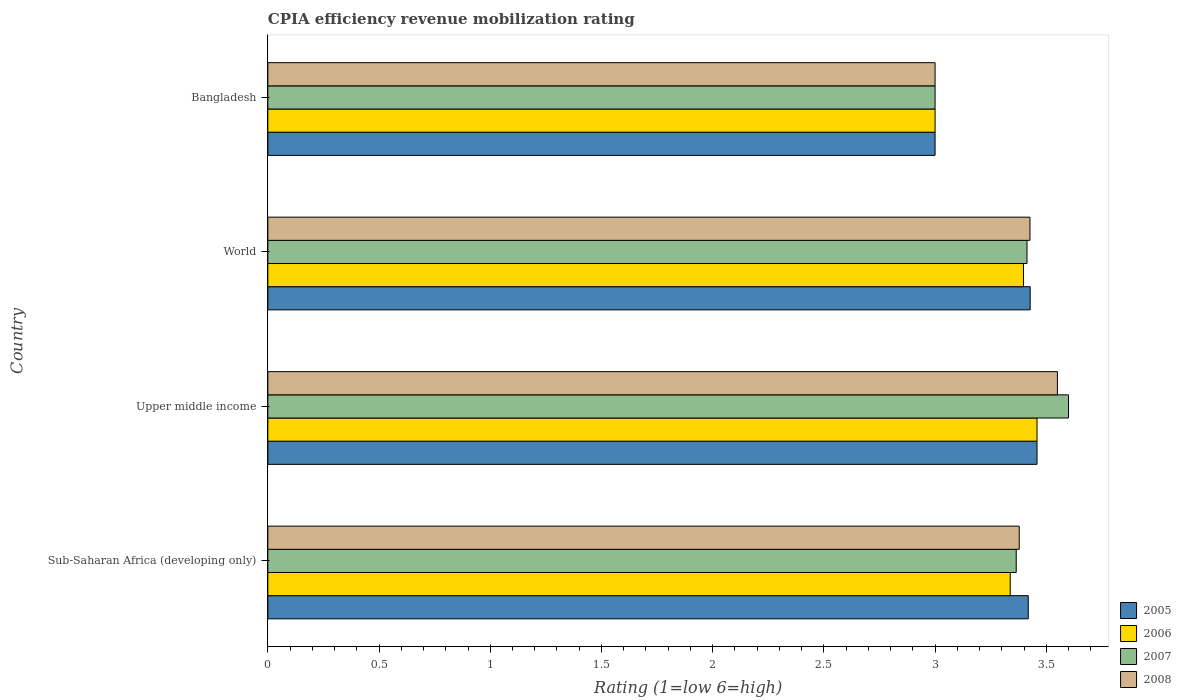How many different coloured bars are there?
Offer a very short reply. 4. How many bars are there on the 2nd tick from the top?
Ensure brevity in your answer.  4. What is the label of the 4th group of bars from the top?
Give a very brief answer. Sub-Saharan Africa (developing only). In how many cases, is the number of bars for a given country not equal to the number of legend labels?
Provide a succinct answer. 0. What is the CPIA rating in 2007 in Upper middle income?
Provide a succinct answer. 3.6. Across all countries, what is the maximum CPIA rating in 2005?
Provide a short and direct response. 3.46. Across all countries, what is the minimum CPIA rating in 2007?
Keep it short and to the point. 3. In which country was the CPIA rating in 2005 maximum?
Your response must be concise. Upper middle income. In which country was the CPIA rating in 2005 minimum?
Ensure brevity in your answer.  Bangladesh. What is the total CPIA rating in 2006 in the graph?
Ensure brevity in your answer.  13.19. What is the difference between the CPIA rating in 2007 in Bangladesh and that in World?
Your answer should be very brief. -0.41. What is the difference between the CPIA rating in 2006 in Bangladesh and the CPIA rating in 2005 in Sub-Saharan Africa (developing only)?
Offer a terse response. -0.42. What is the average CPIA rating in 2006 per country?
Your answer should be very brief. 3.3. What is the difference between the CPIA rating in 2008 and CPIA rating in 2005 in Sub-Saharan Africa (developing only)?
Provide a succinct answer. -0.04. What is the ratio of the CPIA rating in 2007 in Sub-Saharan Africa (developing only) to that in World?
Your answer should be very brief. 0.99. Is the CPIA rating in 2008 in Sub-Saharan Africa (developing only) less than that in World?
Make the answer very short. Yes. Is the difference between the CPIA rating in 2008 in Upper middle income and World greater than the difference between the CPIA rating in 2005 in Upper middle income and World?
Keep it short and to the point. Yes. What is the difference between the highest and the second highest CPIA rating in 2008?
Provide a succinct answer. 0.12. What is the difference between the highest and the lowest CPIA rating in 2007?
Give a very brief answer. 0.6. In how many countries, is the CPIA rating in 2007 greater than the average CPIA rating in 2007 taken over all countries?
Make the answer very short. 3. Is the sum of the CPIA rating in 2007 in Bangladesh and World greater than the maximum CPIA rating in 2006 across all countries?
Give a very brief answer. Yes. Is it the case that in every country, the sum of the CPIA rating in 2006 and CPIA rating in 2005 is greater than the sum of CPIA rating in 2008 and CPIA rating in 2007?
Your response must be concise. No. Are all the bars in the graph horizontal?
Offer a very short reply. Yes. What is the difference between two consecutive major ticks on the X-axis?
Ensure brevity in your answer.  0.5. Does the graph contain grids?
Your answer should be very brief. No. How many legend labels are there?
Your answer should be compact. 4. What is the title of the graph?
Your response must be concise. CPIA efficiency revenue mobilization rating. What is the label or title of the X-axis?
Make the answer very short. Rating (1=low 6=high). What is the label or title of the Y-axis?
Make the answer very short. Country. What is the Rating (1=low 6=high) of 2005 in Sub-Saharan Africa (developing only)?
Your response must be concise. 3.42. What is the Rating (1=low 6=high) in 2006 in Sub-Saharan Africa (developing only)?
Provide a short and direct response. 3.34. What is the Rating (1=low 6=high) in 2007 in Sub-Saharan Africa (developing only)?
Provide a succinct answer. 3.36. What is the Rating (1=low 6=high) of 2008 in Sub-Saharan Africa (developing only)?
Give a very brief answer. 3.38. What is the Rating (1=low 6=high) of 2005 in Upper middle income?
Make the answer very short. 3.46. What is the Rating (1=low 6=high) of 2006 in Upper middle income?
Make the answer very short. 3.46. What is the Rating (1=low 6=high) of 2008 in Upper middle income?
Make the answer very short. 3.55. What is the Rating (1=low 6=high) of 2005 in World?
Offer a very short reply. 3.43. What is the Rating (1=low 6=high) of 2006 in World?
Ensure brevity in your answer.  3.4. What is the Rating (1=low 6=high) in 2007 in World?
Provide a short and direct response. 3.41. What is the Rating (1=low 6=high) in 2008 in World?
Provide a succinct answer. 3.43. What is the Rating (1=low 6=high) of 2008 in Bangladesh?
Offer a very short reply. 3. Across all countries, what is the maximum Rating (1=low 6=high) in 2005?
Ensure brevity in your answer.  3.46. Across all countries, what is the maximum Rating (1=low 6=high) of 2006?
Your answer should be compact. 3.46. Across all countries, what is the maximum Rating (1=low 6=high) of 2007?
Offer a terse response. 3.6. Across all countries, what is the maximum Rating (1=low 6=high) in 2008?
Give a very brief answer. 3.55. Across all countries, what is the minimum Rating (1=low 6=high) in 2006?
Give a very brief answer. 3. Across all countries, what is the minimum Rating (1=low 6=high) in 2007?
Ensure brevity in your answer.  3. What is the total Rating (1=low 6=high) in 2005 in the graph?
Ensure brevity in your answer.  13.3. What is the total Rating (1=low 6=high) of 2006 in the graph?
Your answer should be compact. 13.19. What is the total Rating (1=low 6=high) in 2007 in the graph?
Keep it short and to the point. 13.38. What is the total Rating (1=low 6=high) of 2008 in the graph?
Provide a short and direct response. 13.36. What is the difference between the Rating (1=low 6=high) of 2005 in Sub-Saharan Africa (developing only) and that in Upper middle income?
Provide a succinct answer. -0.04. What is the difference between the Rating (1=low 6=high) in 2006 in Sub-Saharan Africa (developing only) and that in Upper middle income?
Provide a short and direct response. -0.12. What is the difference between the Rating (1=low 6=high) in 2007 in Sub-Saharan Africa (developing only) and that in Upper middle income?
Ensure brevity in your answer.  -0.24. What is the difference between the Rating (1=low 6=high) in 2008 in Sub-Saharan Africa (developing only) and that in Upper middle income?
Offer a very short reply. -0.17. What is the difference between the Rating (1=low 6=high) of 2005 in Sub-Saharan Africa (developing only) and that in World?
Provide a short and direct response. -0.01. What is the difference between the Rating (1=low 6=high) in 2006 in Sub-Saharan Africa (developing only) and that in World?
Give a very brief answer. -0.06. What is the difference between the Rating (1=low 6=high) of 2007 in Sub-Saharan Africa (developing only) and that in World?
Provide a succinct answer. -0.05. What is the difference between the Rating (1=low 6=high) in 2008 in Sub-Saharan Africa (developing only) and that in World?
Offer a terse response. -0.05. What is the difference between the Rating (1=low 6=high) in 2005 in Sub-Saharan Africa (developing only) and that in Bangladesh?
Offer a very short reply. 0.42. What is the difference between the Rating (1=low 6=high) of 2006 in Sub-Saharan Africa (developing only) and that in Bangladesh?
Provide a succinct answer. 0.34. What is the difference between the Rating (1=low 6=high) in 2007 in Sub-Saharan Africa (developing only) and that in Bangladesh?
Your answer should be very brief. 0.36. What is the difference between the Rating (1=low 6=high) of 2008 in Sub-Saharan Africa (developing only) and that in Bangladesh?
Provide a short and direct response. 0.38. What is the difference between the Rating (1=low 6=high) in 2005 in Upper middle income and that in World?
Offer a very short reply. 0.03. What is the difference between the Rating (1=low 6=high) in 2006 in Upper middle income and that in World?
Provide a short and direct response. 0.06. What is the difference between the Rating (1=low 6=high) of 2007 in Upper middle income and that in World?
Offer a very short reply. 0.19. What is the difference between the Rating (1=low 6=high) of 2008 in Upper middle income and that in World?
Offer a terse response. 0.12. What is the difference between the Rating (1=low 6=high) of 2005 in Upper middle income and that in Bangladesh?
Provide a succinct answer. 0.46. What is the difference between the Rating (1=low 6=high) in 2006 in Upper middle income and that in Bangladesh?
Offer a very short reply. 0.46. What is the difference between the Rating (1=low 6=high) in 2007 in Upper middle income and that in Bangladesh?
Provide a succinct answer. 0.6. What is the difference between the Rating (1=low 6=high) in 2008 in Upper middle income and that in Bangladesh?
Provide a succinct answer. 0.55. What is the difference between the Rating (1=low 6=high) in 2005 in World and that in Bangladesh?
Your answer should be very brief. 0.43. What is the difference between the Rating (1=low 6=high) in 2006 in World and that in Bangladesh?
Make the answer very short. 0.4. What is the difference between the Rating (1=low 6=high) of 2007 in World and that in Bangladesh?
Your answer should be very brief. 0.41. What is the difference between the Rating (1=low 6=high) of 2008 in World and that in Bangladesh?
Give a very brief answer. 0.43. What is the difference between the Rating (1=low 6=high) of 2005 in Sub-Saharan Africa (developing only) and the Rating (1=low 6=high) of 2006 in Upper middle income?
Your answer should be very brief. -0.04. What is the difference between the Rating (1=low 6=high) in 2005 in Sub-Saharan Africa (developing only) and the Rating (1=low 6=high) in 2007 in Upper middle income?
Offer a very short reply. -0.18. What is the difference between the Rating (1=low 6=high) of 2005 in Sub-Saharan Africa (developing only) and the Rating (1=low 6=high) of 2008 in Upper middle income?
Make the answer very short. -0.13. What is the difference between the Rating (1=low 6=high) in 2006 in Sub-Saharan Africa (developing only) and the Rating (1=low 6=high) in 2007 in Upper middle income?
Provide a short and direct response. -0.26. What is the difference between the Rating (1=low 6=high) of 2006 in Sub-Saharan Africa (developing only) and the Rating (1=low 6=high) of 2008 in Upper middle income?
Give a very brief answer. -0.21. What is the difference between the Rating (1=low 6=high) of 2007 in Sub-Saharan Africa (developing only) and the Rating (1=low 6=high) of 2008 in Upper middle income?
Provide a succinct answer. -0.19. What is the difference between the Rating (1=low 6=high) in 2005 in Sub-Saharan Africa (developing only) and the Rating (1=low 6=high) in 2006 in World?
Provide a short and direct response. 0.02. What is the difference between the Rating (1=low 6=high) of 2005 in Sub-Saharan Africa (developing only) and the Rating (1=low 6=high) of 2007 in World?
Your answer should be compact. 0.01. What is the difference between the Rating (1=low 6=high) of 2005 in Sub-Saharan Africa (developing only) and the Rating (1=low 6=high) of 2008 in World?
Your response must be concise. -0.01. What is the difference between the Rating (1=low 6=high) in 2006 in Sub-Saharan Africa (developing only) and the Rating (1=low 6=high) in 2007 in World?
Offer a terse response. -0.08. What is the difference between the Rating (1=low 6=high) of 2006 in Sub-Saharan Africa (developing only) and the Rating (1=low 6=high) of 2008 in World?
Provide a short and direct response. -0.09. What is the difference between the Rating (1=low 6=high) in 2007 in Sub-Saharan Africa (developing only) and the Rating (1=low 6=high) in 2008 in World?
Your answer should be very brief. -0.06. What is the difference between the Rating (1=low 6=high) of 2005 in Sub-Saharan Africa (developing only) and the Rating (1=low 6=high) of 2006 in Bangladesh?
Make the answer very short. 0.42. What is the difference between the Rating (1=low 6=high) in 2005 in Sub-Saharan Africa (developing only) and the Rating (1=low 6=high) in 2007 in Bangladesh?
Offer a terse response. 0.42. What is the difference between the Rating (1=low 6=high) of 2005 in Sub-Saharan Africa (developing only) and the Rating (1=low 6=high) of 2008 in Bangladesh?
Your response must be concise. 0.42. What is the difference between the Rating (1=low 6=high) of 2006 in Sub-Saharan Africa (developing only) and the Rating (1=low 6=high) of 2007 in Bangladesh?
Your answer should be compact. 0.34. What is the difference between the Rating (1=low 6=high) of 2006 in Sub-Saharan Africa (developing only) and the Rating (1=low 6=high) of 2008 in Bangladesh?
Your answer should be compact. 0.34. What is the difference between the Rating (1=low 6=high) in 2007 in Sub-Saharan Africa (developing only) and the Rating (1=low 6=high) in 2008 in Bangladesh?
Provide a short and direct response. 0.36. What is the difference between the Rating (1=low 6=high) of 2005 in Upper middle income and the Rating (1=low 6=high) of 2006 in World?
Offer a very short reply. 0.06. What is the difference between the Rating (1=low 6=high) of 2005 in Upper middle income and the Rating (1=low 6=high) of 2007 in World?
Keep it short and to the point. 0.04. What is the difference between the Rating (1=low 6=high) in 2005 in Upper middle income and the Rating (1=low 6=high) in 2008 in World?
Keep it short and to the point. 0.03. What is the difference between the Rating (1=low 6=high) of 2006 in Upper middle income and the Rating (1=low 6=high) of 2007 in World?
Give a very brief answer. 0.04. What is the difference between the Rating (1=low 6=high) in 2006 in Upper middle income and the Rating (1=low 6=high) in 2008 in World?
Your answer should be compact. 0.03. What is the difference between the Rating (1=low 6=high) of 2007 in Upper middle income and the Rating (1=low 6=high) of 2008 in World?
Make the answer very short. 0.17. What is the difference between the Rating (1=low 6=high) in 2005 in Upper middle income and the Rating (1=low 6=high) in 2006 in Bangladesh?
Your answer should be compact. 0.46. What is the difference between the Rating (1=low 6=high) of 2005 in Upper middle income and the Rating (1=low 6=high) of 2007 in Bangladesh?
Your answer should be compact. 0.46. What is the difference between the Rating (1=low 6=high) in 2005 in Upper middle income and the Rating (1=low 6=high) in 2008 in Bangladesh?
Keep it short and to the point. 0.46. What is the difference between the Rating (1=low 6=high) of 2006 in Upper middle income and the Rating (1=low 6=high) of 2007 in Bangladesh?
Ensure brevity in your answer.  0.46. What is the difference between the Rating (1=low 6=high) of 2006 in Upper middle income and the Rating (1=low 6=high) of 2008 in Bangladesh?
Keep it short and to the point. 0.46. What is the difference between the Rating (1=low 6=high) of 2007 in Upper middle income and the Rating (1=low 6=high) of 2008 in Bangladesh?
Ensure brevity in your answer.  0.6. What is the difference between the Rating (1=low 6=high) of 2005 in World and the Rating (1=low 6=high) of 2006 in Bangladesh?
Your answer should be compact. 0.43. What is the difference between the Rating (1=low 6=high) of 2005 in World and the Rating (1=low 6=high) of 2007 in Bangladesh?
Your answer should be compact. 0.43. What is the difference between the Rating (1=low 6=high) in 2005 in World and the Rating (1=low 6=high) in 2008 in Bangladesh?
Your answer should be compact. 0.43. What is the difference between the Rating (1=low 6=high) of 2006 in World and the Rating (1=low 6=high) of 2007 in Bangladesh?
Your answer should be compact. 0.4. What is the difference between the Rating (1=low 6=high) of 2006 in World and the Rating (1=low 6=high) of 2008 in Bangladesh?
Give a very brief answer. 0.4. What is the difference between the Rating (1=low 6=high) of 2007 in World and the Rating (1=low 6=high) of 2008 in Bangladesh?
Your answer should be very brief. 0.41. What is the average Rating (1=low 6=high) in 2005 per country?
Ensure brevity in your answer.  3.33. What is the average Rating (1=low 6=high) in 2006 per country?
Ensure brevity in your answer.  3.3. What is the average Rating (1=low 6=high) in 2007 per country?
Keep it short and to the point. 3.34. What is the average Rating (1=low 6=high) of 2008 per country?
Offer a terse response. 3.34. What is the difference between the Rating (1=low 6=high) of 2005 and Rating (1=low 6=high) of 2006 in Sub-Saharan Africa (developing only)?
Provide a succinct answer. 0.08. What is the difference between the Rating (1=low 6=high) in 2005 and Rating (1=low 6=high) in 2007 in Sub-Saharan Africa (developing only)?
Your response must be concise. 0.05. What is the difference between the Rating (1=low 6=high) of 2005 and Rating (1=low 6=high) of 2008 in Sub-Saharan Africa (developing only)?
Your answer should be very brief. 0.04. What is the difference between the Rating (1=low 6=high) of 2006 and Rating (1=low 6=high) of 2007 in Sub-Saharan Africa (developing only)?
Your answer should be compact. -0.03. What is the difference between the Rating (1=low 6=high) in 2006 and Rating (1=low 6=high) in 2008 in Sub-Saharan Africa (developing only)?
Provide a short and direct response. -0.04. What is the difference between the Rating (1=low 6=high) of 2007 and Rating (1=low 6=high) of 2008 in Sub-Saharan Africa (developing only)?
Your response must be concise. -0.01. What is the difference between the Rating (1=low 6=high) of 2005 and Rating (1=low 6=high) of 2007 in Upper middle income?
Your response must be concise. -0.14. What is the difference between the Rating (1=low 6=high) in 2005 and Rating (1=low 6=high) in 2008 in Upper middle income?
Provide a succinct answer. -0.09. What is the difference between the Rating (1=low 6=high) of 2006 and Rating (1=low 6=high) of 2007 in Upper middle income?
Your response must be concise. -0.14. What is the difference between the Rating (1=low 6=high) of 2006 and Rating (1=low 6=high) of 2008 in Upper middle income?
Your answer should be compact. -0.09. What is the difference between the Rating (1=low 6=high) of 2005 and Rating (1=low 6=high) of 2006 in World?
Your response must be concise. 0.03. What is the difference between the Rating (1=low 6=high) in 2005 and Rating (1=low 6=high) in 2007 in World?
Give a very brief answer. 0.01. What is the difference between the Rating (1=low 6=high) in 2006 and Rating (1=low 6=high) in 2007 in World?
Provide a short and direct response. -0.02. What is the difference between the Rating (1=low 6=high) of 2006 and Rating (1=low 6=high) of 2008 in World?
Ensure brevity in your answer.  -0.03. What is the difference between the Rating (1=low 6=high) of 2007 and Rating (1=low 6=high) of 2008 in World?
Keep it short and to the point. -0.01. What is the difference between the Rating (1=low 6=high) of 2005 and Rating (1=low 6=high) of 2006 in Bangladesh?
Give a very brief answer. 0. What is the difference between the Rating (1=low 6=high) of 2006 and Rating (1=low 6=high) of 2008 in Bangladesh?
Give a very brief answer. 0. What is the ratio of the Rating (1=low 6=high) of 2006 in Sub-Saharan Africa (developing only) to that in Upper middle income?
Offer a very short reply. 0.97. What is the ratio of the Rating (1=low 6=high) in 2007 in Sub-Saharan Africa (developing only) to that in Upper middle income?
Offer a very short reply. 0.93. What is the ratio of the Rating (1=low 6=high) of 2008 in Sub-Saharan Africa (developing only) to that in Upper middle income?
Provide a succinct answer. 0.95. What is the ratio of the Rating (1=low 6=high) in 2006 in Sub-Saharan Africa (developing only) to that in World?
Your answer should be very brief. 0.98. What is the ratio of the Rating (1=low 6=high) in 2007 in Sub-Saharan Africa (developing only) to that in World?
Offer a terse response. 0.99. What is the ratio of the Rating (1=low 6=high) of 2008 in Sub-Saharan Africa (developing only) to that in World?
Your answer should be very brief. 0.99. What is the ratio of the Rating (1=low 6=high) of 2005 in Sub-Saharan Africa (developing only) to that in Bangladesh?
Make the answer very short. 1.14. What is the ratio of the Rating (1=low 6=high) of 2006 in Sub-Saharan Africa (developing only) to that in Bangladesh?
Your response must be concise. 1.11. What is the ratio of the Rating (1=low 6=high) of 2007 in Sub-Saharan Africa (developing only) to that in Bangladesh?
Offer a very short reply. 1.12. What is the ratio of the Rating (1=low 6=high) of 2008 in Sub-Saharan Africa (developing only) to that in Bangladesh?
Ensure brevity in your answer.  1.13. What is the ratio of the Rating (1=low 6=high) of 2006 in Upper middle income to that in World?
Make the answer very short. 1.02. What is the ratio of the Rating (1=low 6=high) in 2007 in Upper middle income to that in World?
Make the answer very short. 1.05. What is the ratio of the Rating (1=low 6=high) in 2008 in Upper middle income to that in World?
Your response must be concise. 1.04. What is the ratio of the Rating (1=low 6=high) of 2005 in Upper middle income to that in Bangladesh?
Give a very brief answer. 1.15. What is the ratio of the Rating (1=low 6=high) of 2006 in Upper middle income to that in Bangladesh?
Provide a succinct answer. 1.15. What is the ratio of the Rating (1=low 6=high) of 2008 in Upper middle income to that in Bangladesh?
Your answer should be compact. 1.18. What is the ratio of the Rating (1=low 6=high) of 2005 in World to that in Bangladesh?
Give a very brief answer. 1.14. What is the ratio of the Rating (1=low 6=high) of 2006 in World to that in Bangladesh?
Ensure brevity in your answer.  1.13. What is the ratio of the Rating (1=low 6=high) of 2007 in World to that in Bangladesh?
Offer a terse response. 1.14. What is the ratio of the Rating (1=low 6=high) in 2008 in World to that in Bangladesh?
Your answer should be compact. 1.14. What is the difference between the highest and the second highest Rating (1=low 6=high) of 2005?
Your response must be concise. 0.03. What is the difference between the highest and the second highest Rating (1=low 6=high) in 2006?
Offer a terse response. 0.06. What is the difference between the highest and the second highest Rating (1=low 6=high) of 2007?
Your answer should be compact. 0.19. What is the difference between the highest and the second highest Rating (1=low 6=high) in 2008?
Ensure brevity in your answer.  0.12. What is the difference between the highest and the lowest Rating (1=low 6=high) in 2005?
Your answer should be compact. 0.46. What is the difference between the highest and the lowest Rating (1=low 6=high) in 2006?
Make the answer very short. 0.46. What is the difference between the highest and the lowest Rating (1=low 6=high) in 2007?
Offer a terse response. 0.6. What is the difference between the highest and the lowest Rating (1=low 6=high) of 2008?
Provide a short and direct response. 0.55. 